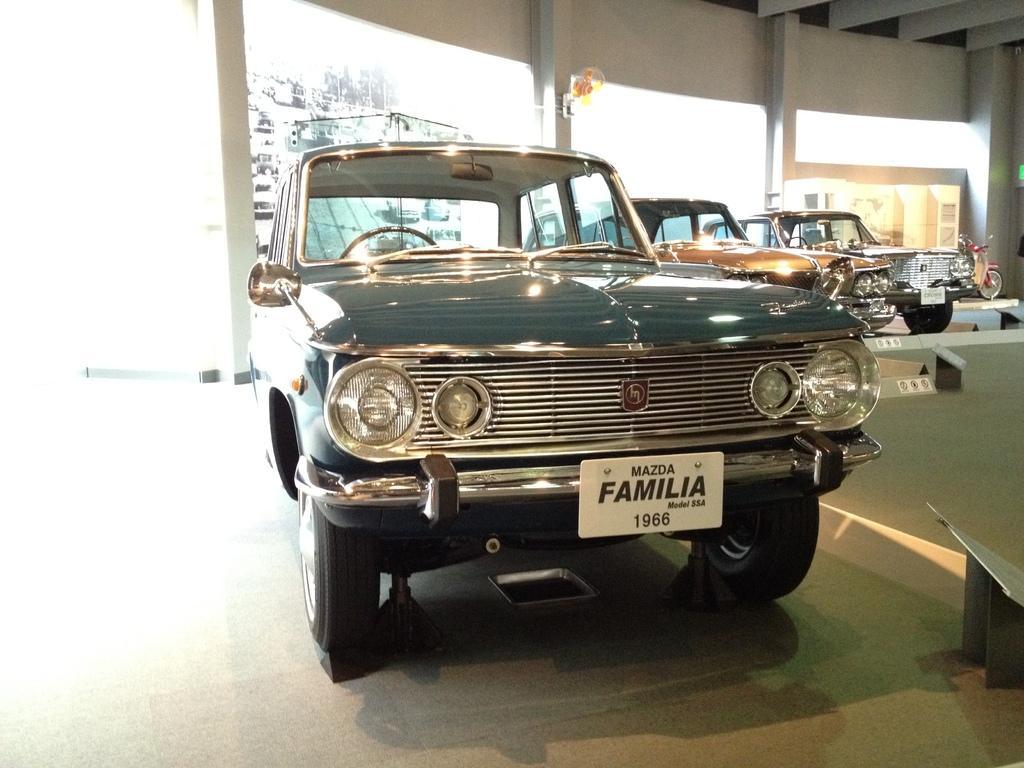Please provide a concise description of this image. In this image there is a wall towards the top of the image, there are pillars, there is an object on the pillar, there is ground towards the bottom of the image, there is an object towards the right of the image, there are vehicles on the ground, the background of the image is white in color. 